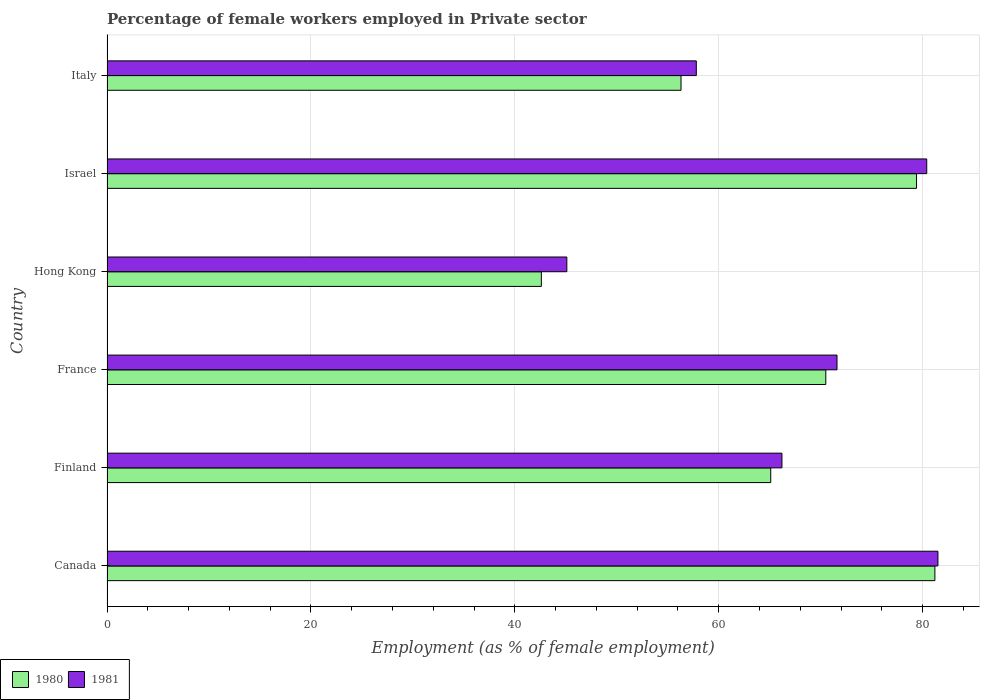How many groups of bars are there?
Keep it short and to the point. 6. Are the number of bars per tick equal to the number of legend labels?
Give a very brief answer. Yes. Are the number of bars on each tick of the Y-axis equal?
Your answer should be very brief. Yes. How many bars are there on the 4th tick from the top?
Your response must be concise. 2. What is the label of the 2nd group of bars from the top?
Give a very brief answer. Israel. In how many cases, is the number of bars for a given country not equal to the number of legend labels?
Ensure brevity in your answer.  0. What is the percentage of females employed in Private sector in 1980 in Canada?
Your answer should be very brief. 81.2. Across all countries, what is the maximum percentage of females employed in Private sector in 1980?
Offer a terse response. 81.2. Across all countries, what is the minimum percentage of females employed in Private sector in 1980?
Provide a short and direct response. 42.6. In which country was the percentage of females employed in Private sector in 1981 minimum?
Your answer should be very brief. Hong Kong. What is the total percentage of females employed in Private sector in 1981 in the graph?
Your answer should be compact. 402.6. What is the difference between the percentage of females employed in Private sector in 1980 in Canada and that in Hong Kong?
Offer a terse response. 38.6. What is the difference between the percentage of females employed in Private sector in 1981 in Finland and the percentage of females employed in Private sector in 1980 in Israel?
Your answer should be compact. -13.2. What is the average percentage of females employed in Private sector in 1981 per country?
Your answer should be very brief. 67.1. What is the ratio of the percentage of females employed in Private sector in 1980 in Finland to that in Hong Kong?
Offer a terse response. 1.53. Is the difference between the percentage of females employed in Private sector in 1981 in Canada and Finland greater than the difference between the percentage of females employed in Private sector in 1980 in Canada and Finland?
Ensure brevity in your answer.  No. What is the difference between the highest and the second highest percentage of females employed in Private sector in 1980?
Your answer should be compact. 1.8. What is the difference between the highest and the lowest percentage of females employed in Private sector in 1981?
Keep it short and to the point. 36.4. Is the sum of the percentage of females employed in Private sector in 1980 in Canada and Italy greater than the maximum percentage of females employed in Private sector in 1981 across all countries?
Your response must be concise. Yes. What does the 2nd bar from the bottom in Canada represents?
Your response must be concise. 1981. How many countries are there in the graph?
Offer a very short reply. 6. Does the graph contain grids?
Offer a terse response. Yes. Where does the legend appear in the graph?
Provide a short and direct response. Bottom left. How are the legend labels stacked?
Offer a terse response. Horizontal. What is the title of the graph?
Your answer should be very brief. Percentage of female workers employed in Private sector. What is the label or title of the X-axis?
Your answer should be compact. Employment (as % of female employment). What is the Employment (as % of female employment) in 1980 in Canada?
Keep it short and to the point. 81.2. What is the Employment (as % of female employment) of 1981 in Canada?
Keep it short and to the point. 81.5. What is the Employment (as % of female employment) of 1980 in Finland?
Your answer should be compact. 65.1. What is the Employment (as % of female employment) of 1981 in Finland?
Offer a very short reply. 66.2. What is the Employment (as % of female employment) of 1980 in France?
Your answer should be compact. 70.5. What is the Employment (as % of female employment) of 1981 in France?
Ensure brevity in your answer.  71.6. What is the Employment (as % of female employment) of 1980 in Hong Kong?
Your response must be concise. 42.6. What is the Employment (as % of female employment) in 1981 in Hong Kong?
Your answer should be compact. 45.1. What is the Employment (as % of female employment) in 1980 in Israel?
Provide a short and direct response. 79.4. What is the Employment (as % of female employment) of 1981 in Israel?
Your answer should be compact. 80.4. What is the Employment (as % of female employment) of 1980 in Italy?
Offer a very short reply. 56.3. What is the Employment (as % of female employment) of 1981 in Italy?
Provide a succinct answer. 57.8. Across all countries, what is the maximum Employment (as % of female employment) in 1980?
Provide a succinct answer. 81.2. Across all countries, what is the maximum Employment (as % of female employment) in 1981?
Ensure brevity in your answer.  81.5. Across all countries, what is the minimum Employment (as % of female employment) in 1980?
Give a very brief answer. 42.6. Across all countries, what is the minimum Employment (as % of female employment) of 1981?
Ensure brevity in your answer.  45.1. What is the total Employment (as % of female employment) in 1980 in the graph?
Provide a short and direct response. 395.1. What is the total Employment (as % of female employment) of 1981 in the graph?
Offer a very short reply. 402.6. What is the difference between the Employment (as % of female employment) of 1980 in Canada and that in Finland?
Offer a terse response. 16.1. What is the difference between the Employment (as % of female employment) in 1980 in Canada and that in Hong Kong?
Offer a terse response. 38.6. What is the difference between the Employment (as % of female employment) in 1981 in Canada and that in Hong Kong?
Provide a succinct answer. 36.4. What is the difference between the Employment (as % of female employment) in 1980 in Canada and that in Israel?
Ensure brevity in your answer.  1.8. What is the difference between the Employment (as % of female employment) in 1980 in Canada and that in Italy?
Your answer should be compact. 24.9. What is the difference between the Employment (as % of female employment) of 1981 in Canada and that in Italy?
Your response must be concise. 23.7. What is the difference between the Employment (as % of female employment) of 1980 in Finland and that in France?
Give a very brief answer. -5.4. What is the difference between the Employment (as % of female employment) in 1980 in Finland and that in Hong Kong?
Keep it short and to the point. 22.5. What is the difference between the Employment (as % of female employment) of 1981 in Finland and that in Hong Kong?
Give a very brief answer. 21.1. What is the difference between the Employment (as % of female employment) of 1980 in Finland and that in Israel?
Offer a very short reply. -14.3. What is the difference between the Employment (as % of female employment) in 1981 in Finland and that in Israel?
Provide a succinct answer. -14.2. What is the difference between the Employment (as % of female employment) of 1980 in Finland and that in Italy?
Offer a terse response. 8.8. What is the difference between the Employment (as % of female employment) in 1981 in Finland and that in Italy?
Provide a short and direct response. 8.4. What is the difference between the Employment (as % of female employment) of 1980 in France and that in Hong Kong?
Keep it short and to the point. 27.9. What is the difference between the Employment (as % of female employment) in 1981 in France and that in Hong Kong?
Your answer should be very brief. 26.5. What is the difference between the Employment (as % of female employment) of 1980 in France and that in Israel?
Provide a succinct answer. -8.9. What is the difference between the Employment (as % of female employment) of 1980 in Hong Kong and that in Israel?
Your answer should be compact. -36.8. What is the difference between the Employment (as % of female employment) in 1981 in Hong Kong and that in Israel?
Offer a very short reply. -35.3. What is the difference between the Employment (as % of female employment) in 1980 in Hong Kong and that in Italy?
Your answer should be compact. -13.7. What is the difference between the Employment (as % of female employment) of 1981 in Hong Kong and that in Italy?
Your answer should be compact. -12.7. What is the difference between the Employment (as % of female employment) in 1980 in Israel and that in Italy?
Your answer should be compact. 23.1. What is the difference between the Employment (as % of female employment) of 1981 in Israel and that in Italy?
Provide a short and direct response. 22.6. What is the difference between the Employment (as % of female employment) in 1980 in Canada and the Employment (as % of female employment) in 1981 in France?
Offer a very short reply. 9.6. What is the difference between the Employment (as % of female employment) in 1980 in Canada and the Employment (as % of female employment) in 1981 in Hong Kong?
Provide a short and direct response. 36.1. What is the difference between the Employment (as % of female employment) in 1980 in Canada and the Employment (as % of female employment) in 1981 in Israel?
Your answer should be compact. 0.8. What is the difference between the Employment (as % of female employment) of 1980 in Canada and the Employment (as % of female employment) of 1981 in Italy?
Ensure brevity in your answer.  23.4. What is the difference between the Employment (as % of female employment) of 1980 in Finland and the Employment (as % of female employment) of 1981 in France?
Offer a very short reply. -6.5. What is the difference between the Employment (as % of female employment) in 1980 in Finland and the Employment (as % of female employment) in 1981 in Israel?
Provide a short and direct response. -15.3. What is the difference between the Employment (as % of female employment) in 1980 in Finland and the Employment (as % of female employment) in 1981 in Italy?
Your answer should be very brief. 7.3. What is the difference between the Employment (as % of female employment) in 1980 in France and the Employment (as % of female employment) in 1981 in Hong Kong?
Offer a terse response. 25.4. What is the difference between the Employment (as % of female employment) in 1980 in France and the Employment (as % of female employment) in 1981 in Italy?
Provide a succinct answer. 12.7. What is the difference between the Employment (as % of female employment) of 1980 in Hong Kong and the Employment (as % of female employment) of 1981 in Israel?
Your answer should be compact. -37.8. What is the difference between the Employment (as % of female employment) of 1980 in Hong Kong and the Employment (as % of female employment) of 1981 in Italy?
Offer a very short reply. -15.2. What is the difference between the Employment (as % of female employment) of 1980 in Israel and the Employment (as % of female employment) of 1981 in Italy?
Provide a succinct answer. 21.6. What is the average Employment (as % of female employment) of 1980 per country?
Offer a terse response. 65.85. What is the average Employment (as % of female employment) in 1981 per country?
Ensure brevity in your answer.  67.1. What is the difference between the Employment (as % of female employment) of 1980 and Employment (as % of female employment) of 1981 in Canada?
Provide a succinct answer. -0.3. What is the difference between the Employment (as % of female employment) of 1980 and Employment (as % of female employment) of 1981 in Finland?
Your response must be concise. -1.1. What is the ratio of the Employment (as % of female employment) of 1980 in Canada to that in Finland?
Provide a succinct answer. 1.25. What is the ratio of the Employment (as % of female employment) of 1981 in Canada to that in Finland?
Keep it short and to the point. 1.23. What is the ratio of the Employment (as % of female employment) of 1980 in Canada to that in France?
Ensure brevity in your answer.  1.15. What is the ratio of the Employment (as % of female employment) in 1981 in Canada to that in France?
Provide a short and direct response. 1.14. What is the ratio of the Employment (as % of female employment) in 1980 in Canada to that in Hong Kong?
Offer a very short reply. 1.91. What is the ratio of the Employment (as % of female employment) of 1981 in Canada to that in Hong Kong?
Provide a short and direct response. 1.81. What is the ratio of the Employment (as % of female employment) of 1980 in Canada to that in Israel?
Your answer should be compact. 1.02. What is the ratio of the Employment (as % of female employment) of 1981 in Canada to that in Israel?
Keep it short and to the point. 1.01. What is the ratio of the Employment (as % of female employment) in 1980 in Canada to that in Italy?
Your response must be concise. 1.44. What is the ratio of the Employment (as % of female employment) in 1981 in Canada to that in Italy?
Offer a very short reply. 1.41. What is the ratio of the Employment (as % of female employment) in 1980 in Finland to that in France?
Your response must be concise. 0.92. What is the ratio of the Employment (as % of female employment) of 1981 in Finland to that in France?
Your answer should be very brief. 0.92. What is the ratio of the Employment (as % of female employment) in 1980 in Finland to that in Hong Kong?
Provide a succinct answer. 1.53. What is the ratio of the Employment (as % of female employment) in 1981 in Finland to that in Hong Kong?
Provide a short and direct response. 1.47. What is the ratio of the Employment (as % of female employment) in 1980 in Finland to that in Israel?
Ensure brevity in your answer.  0.82. What is the ratio of the Employment (as % of female employment) in 1981 in Finland to that in Israel?
Your answer should be compact. 0.82. What is the ratio of the Employment (as % of female employment) of 1980 in Finland to that in Italy?
Ensure brevity in your answer.  1.16. What is the ratio of the Employment (as % of female employment) of 1981 in Finland to that in Italy?
Offer a terse response. 1.15. What is the ratio of the Employment (as % of female employment) in 1980 in France to that in Hong Kong?
Keep it short and to the point. 1.65. What is the ratio of the Employment (as % of female employment) of 1981 in France to that in Hong Kong?
Offer a terse response. 1.59. What is the ratio of the Employment (as % of female employment) of 1980 in France to that in Israel?
Offer a very short reply. 0.89. What is the ratio of the Employment (as % of female employment) in 1981 in France to that in Israel?
Provide a short and direct response. 0.89. What is the ratio of the Employment (as % of female employment) in 1980 in France to that in Italy?
Keep it short and to the point. 1.25. What is the ratio of the Employment (as % of female employment) in 1981 in France to that in Italy?
Your answer should be compact. 1.24. What is the ratio of the Employment (as % of female employment) of 1980 in Hong Kong to that in Israel?
Provide a succinct answer. 0.54. What is the ratio of the Employment (as % of female employment) of 1981 in Hong Kong to that in Israel?
Make the answer very short. 0.56. What is the ratio of the Employment (as % of female employment) of 1980 in Hong Kong to that in Italy?
Provide a short and direct response. 0.76. What is the ratio of the Employment (as % of female employment) of 1981 in Hong Kong to that in Italy?
Offer a terse response. 0.78. What is the ratio of the Employment (as % of female employment) in 1980 in Israel to that in Italy?
Your answer should be compact. 1.41. What is the ratio of the Employment (as % of female employment) in 1981 in Israel to that in Italy?
Offer a very short reply. 1.39. What is the difference between the highest and the second highest Employment (as % of female employment) of 1980?
Make the answer very short. 1.8. What is the difference between the highest and the lowest Employment (as % of female employment) in 1980?
Provide a short and direct response. 38.6. What is the difference between the highest and the lowest Employment (as % of female employment) in 1981?
Provide a short and direct response. 36.4. 